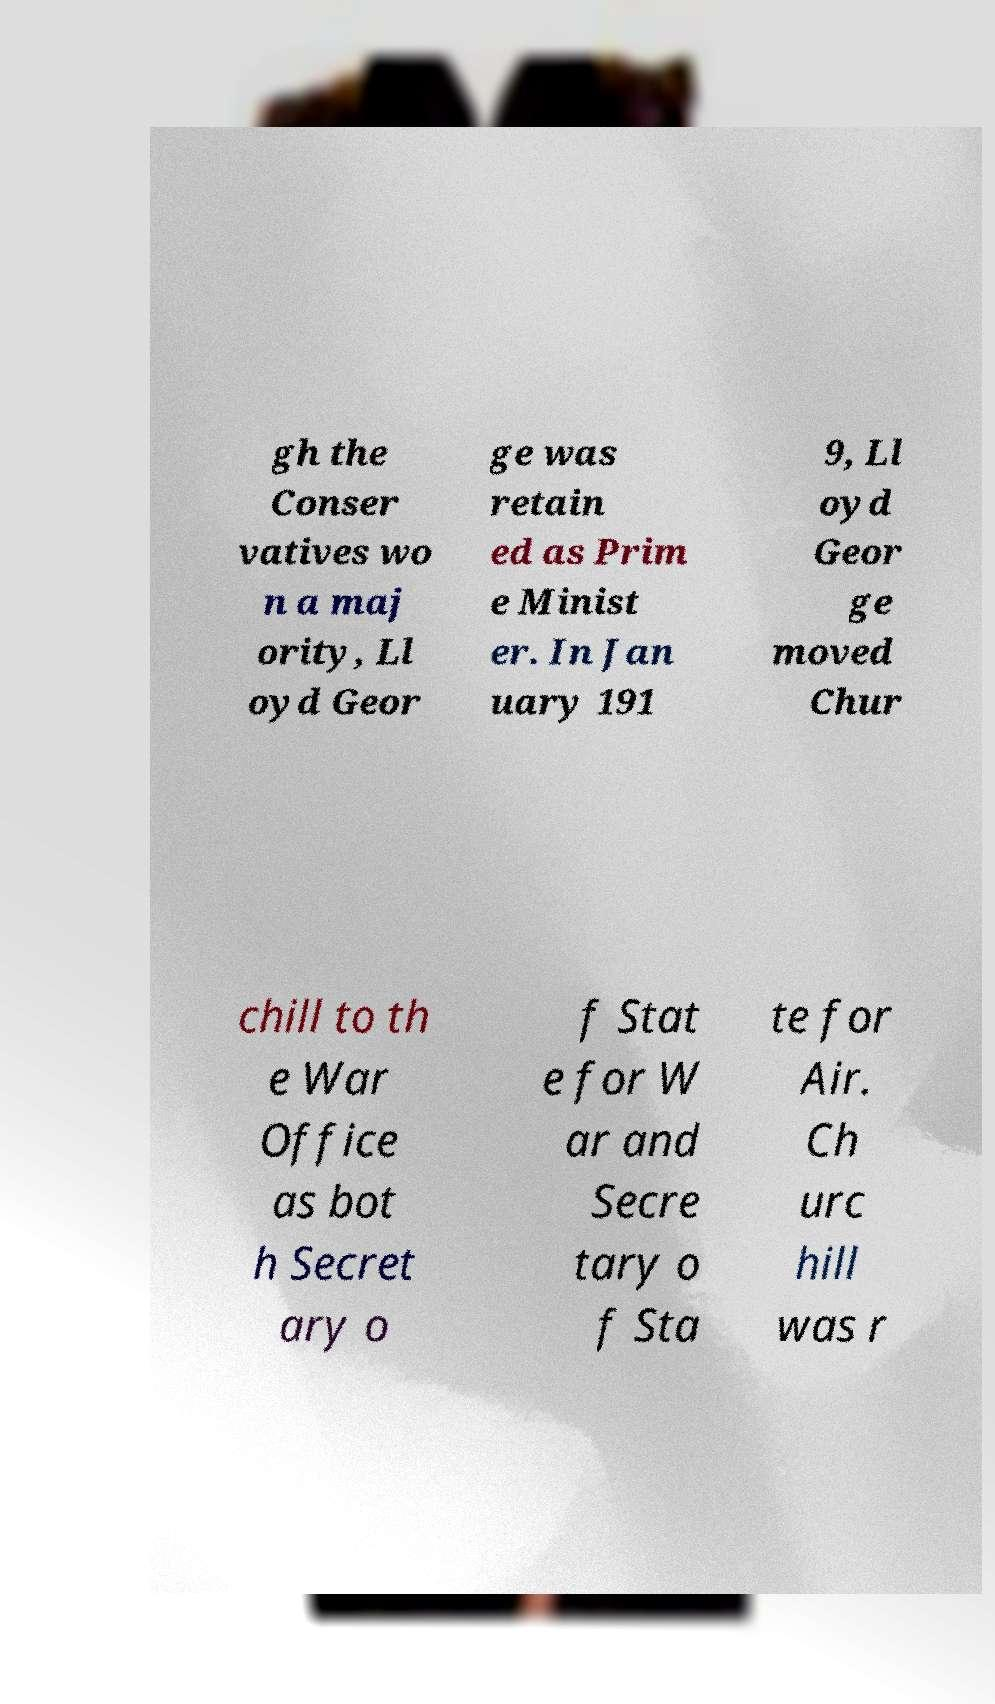There's text embedded in this image that I need extracted. Can you transcribe it verbatim? gh the Conser vatives wo n a maj ority, Ll oyd Geor ge was retain ed as Prim e Minist er. In Jan uary 191 9, Ll oyd Geor ge moved Chur chill to th e War Office as bot h Secret ary o f Stat e for W ar and Secre tary o f Sta te for Air. Ch urc hill was r 